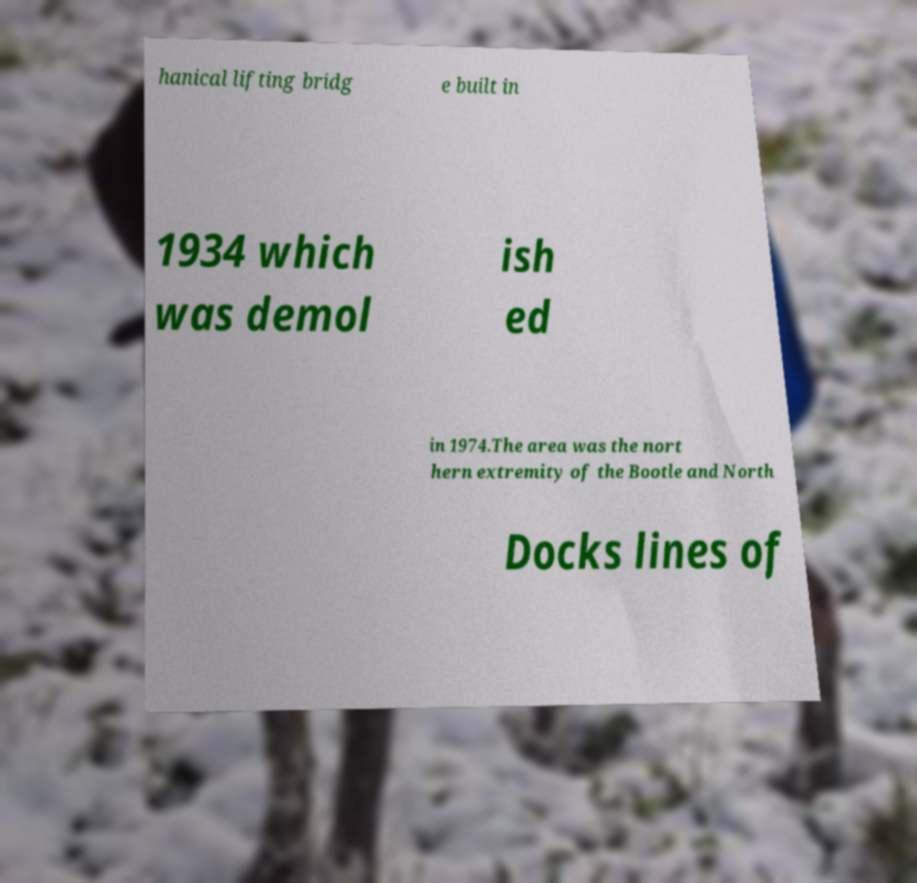For documentation purposes, I need the text within this image transcribed. Could you provide that? hanical lifting bridg e built in 1934 which was demol ish ed in 1974.The area was the nort hern extremity of the Bootle and North Docks lines of 